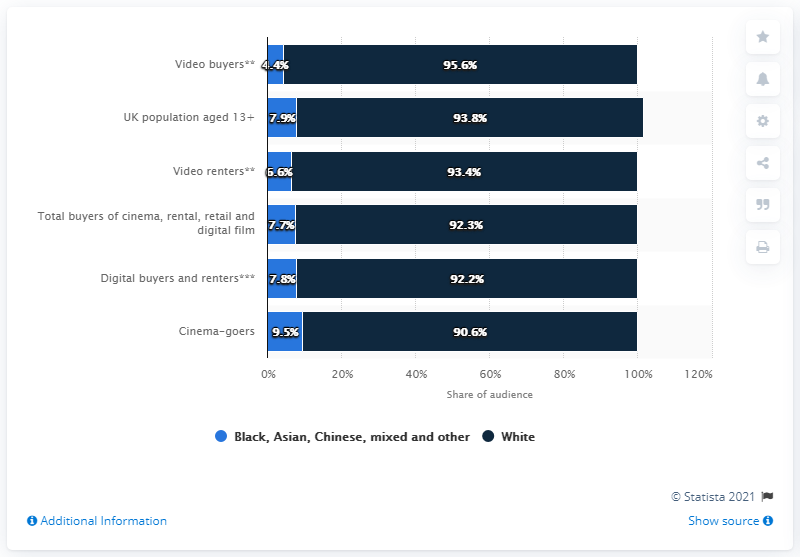Highlight a few significant elements in this photo. In 2015, 4.4% of video buyers in the UK were from black and minority ethnic groups. 